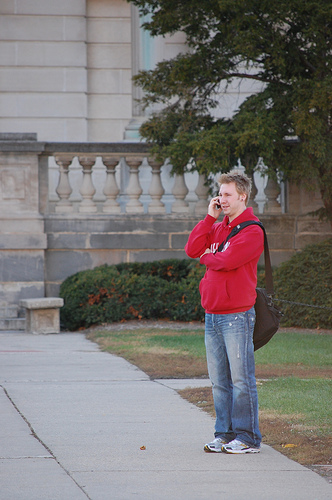<image>What sports team is he a fan of? I am not sure what sports team he is a fan of. It could be 'red sox', 'alabama', 'wisconsin', 'padres', 'cardinals', 'denver', 'jets', or 'cornhuskers'. What sport does this man appear to enjoy? I don't know what sport this man appears to enjoy. It can be football, frisbee, jogging, or biking. What sports team is he a fan of? I don't know what sports team he is a fan of. It can be any of the mentioned options. What sport does this man appear to enjoy? I don't know what sport this man appears to enjoy. It is hard to determine from the given options. 